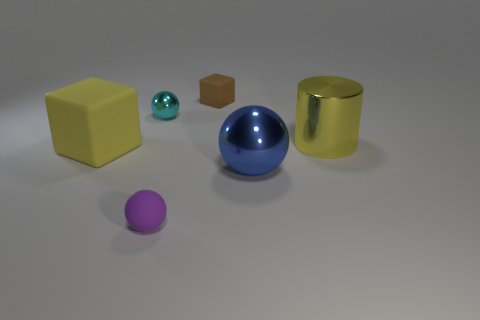Add 1 large brown metal cubes. How many objects exist? 7 Subtract all blocks. How many objects are left? 4 Subtract all tiny brown rubber things. Subtract all tiny cyan metal spheres. How many objects are left? 4 Add 1 cyan spheres. How many cyan spheres are left? 2 Add 3 blue rubber balls. How many blue rubber balls exist? 3 Subtract 1 brown blocks. How many objects are left? 5 